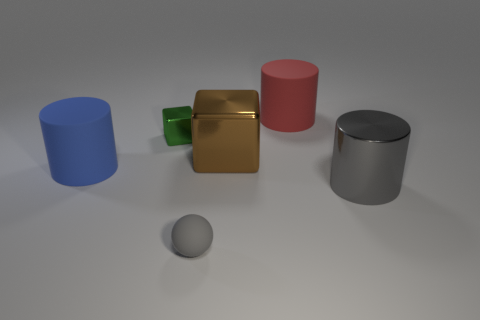Subtract 3 cylinders. How many cylinders are left? 0 Add 4 gray metal things. How many objects exist? 10 Subtract all big matte cylinders. How many cylinders are left? 1 Subtract all spheres. How many objects are left? 5 Subtract all yellow cylinders. How many red blocks are left? 0 Subtract all big blue rubber cylinders. Subtract all gray rubber things. How many objects are left? 4 Add 1 red objects. How many red objects are left? 2 Add 5 brown metallic blocks. How many brown metallic blocks exist? 6 Subtract all red cylinders. How many cylinders are left? 2 Subtract 0 green cylinders. How many objects are left? 6 